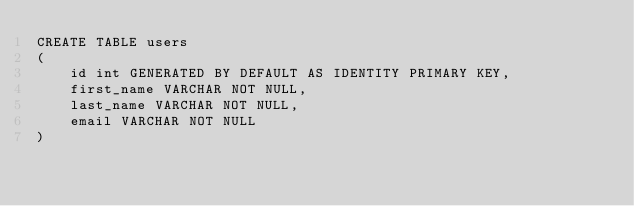<code> <loc_0><loc_0><loc_500><loc_500><_SQL_>CREATE TABLE users
(
    id int GENERATED BY DEFAULT AS IDENTITY PRIMARY KEY,
    first_name VARCHAR NOT NULL,
    last_name VARCHAR NOT NULL,
    email VARCHAR NOT NULL
)</code> 